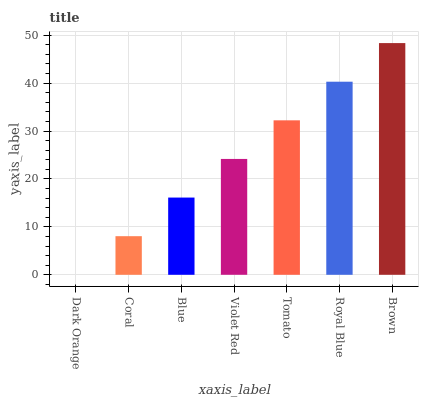Is Brown the maximum?
Answer yes or no. Yes. Is Coral the minimum?
Answer yes or no. No. Is Coral the maximum?
Answer yes or no. No. Is Coral greater than Dark Orange?
Answer yes or no. Yes. Is Dark Orange less than Coral?
Answer yes or no. Yes. Is Dark Orange greater than Coral?
Answer yes or no. No. Is Coral less than Dark Orange?
Answer yes or no. No. Is Violet Red the high median?
Answer yes or no. Yes. Is Violet Red the low median?
Answer yes or no. Yes. Is Royal Blue the high median?
Answer yes or no. No. Is Blue the low median?
Answer yes or no. No. 